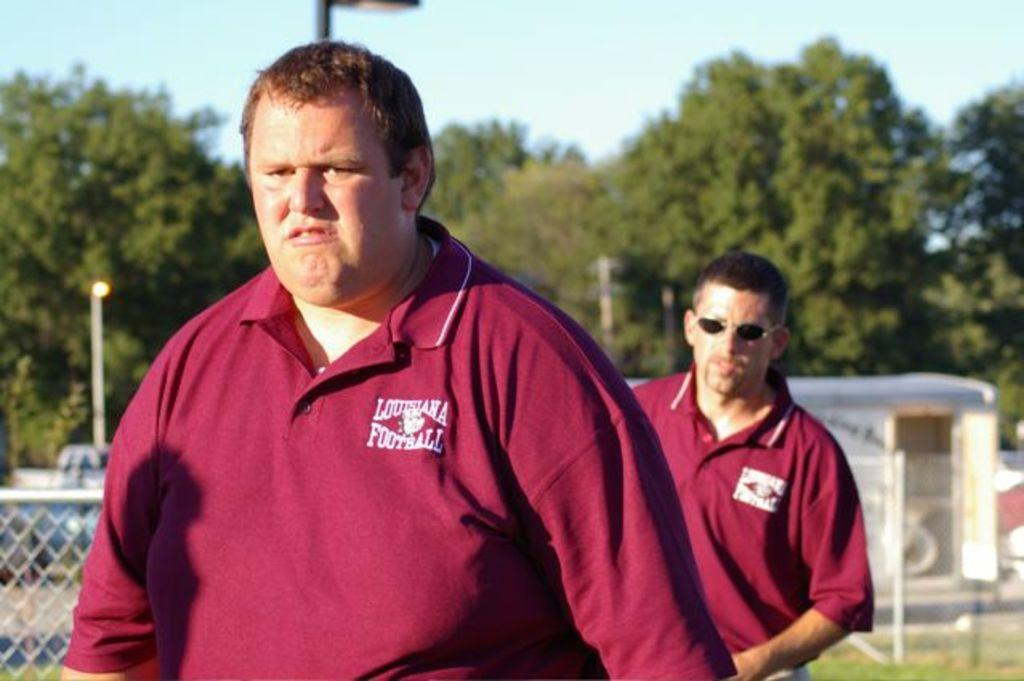<image>
Write a terse but informative summary of the picture. Two men are standing outside with Louisiana Football shirts on 